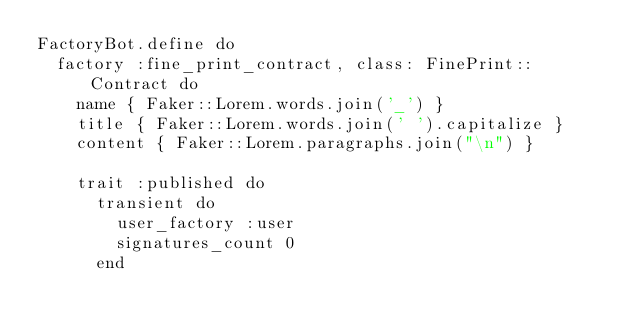<code> <loc_0><loc_0><loc_500><loc_500><_Ruby_>FactoryBot.define do
  factory :fine_print_contract, class: FinePrint::Contract do
    name { Faker::Lorem.words.join('_') }
    title { Faker::Lorem.words.join(' ').capitalize }
    content { Faker::Lorem.paragraphs.join("\n") }

    trait :published do
      transient do
        user_factory :user
        signatures_count 0
      end
</code> 